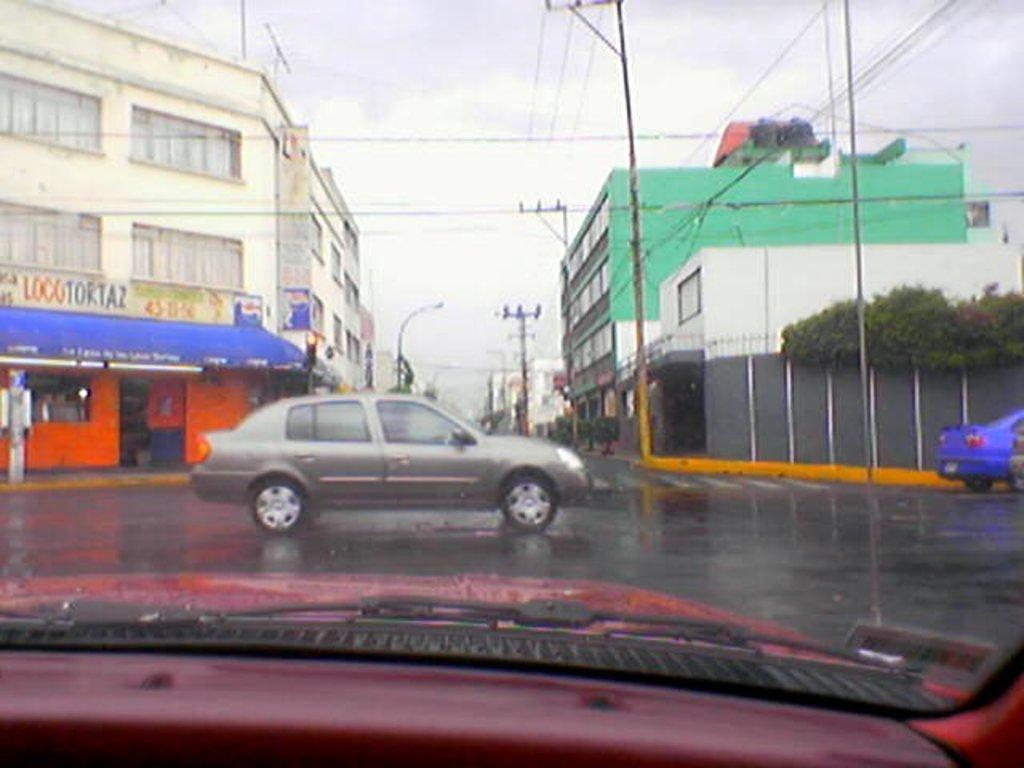Describe this image in one or two sentences. In this image vehicles are moving on road, on either side of the road there are buildings and pole. 